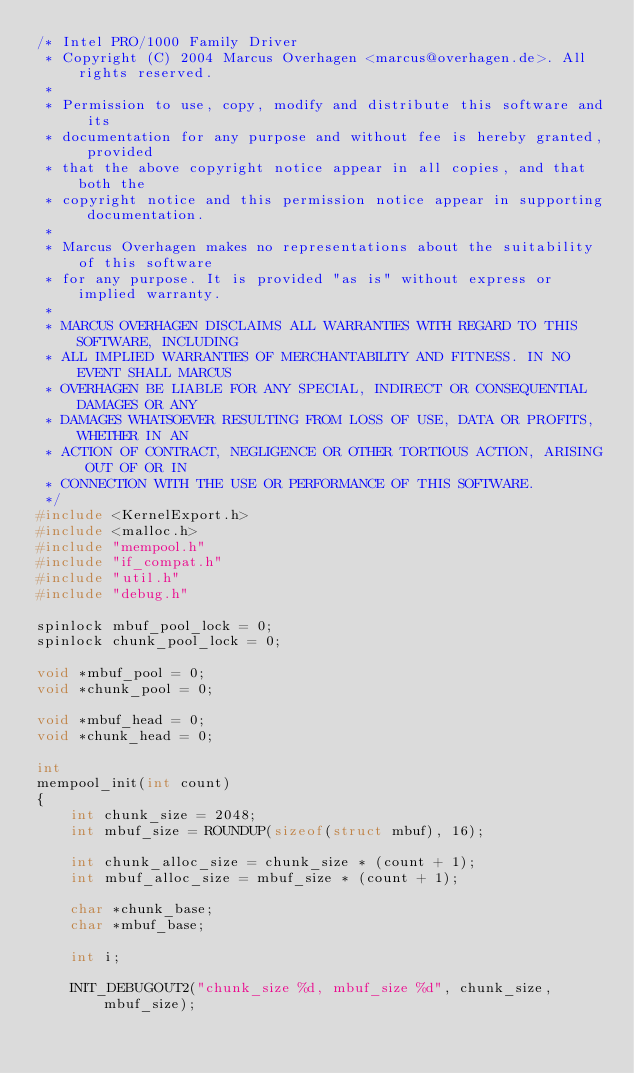<code> <loc_0><loc_0><loc_500><loc_500><_C_>/* Intel PRO/1000 Family Driver
 * Copyright (C) 2004 Marcus Overhagen <marcus@overhagen.de>. All rights reserved.
 *
 * Permission to use, copy, modify and distribute this software and its 
 * documentation for any purpose and without fee is hereby granted, provided
 * that the above copyright notice appear in all copies, and that both the
 * copyright notice and this permission notice appear in supporting documentation.
 *
 * Marcus Overhagen makes no representations about the suitability of this software
 * for any purpose. It is provided "as is" without express or implied warranty.
 *
 * MARCUS OVERHAGEN DISCLAIMS ALL WARRANTIES WITH REGARD TO THIS SOFTWARE, INCLUDING
 * ALL IMPLIED WARRANTIES OF MERCHANTABILITY AND FITNESS. IN NO EVENT SHALL MARCUS
 * OVERHAGEN BE LIABLE FOR ANY SPECIAL, INDIRECT OR CONSEQUENTIAL DAMAGES OR ANY
 * DAMAGES WHATSOEVER RESULTING FROM LOSS OF USE, DATA OR PROFITS, WHETHER IN AN
 * ACTION OF CONTRACT, NEGLIGENCE OR OTHER TORTIOUS ACTION, ARISING OUT OF OR IN
 * CONNECTION WITH THE USE OR PERFORMANCE OF THIS SOFTWARE.
 */
#include <KernelExport.h>
#include <malloc.h>
#include "mempool.h"
#include "if_compat.h"
#include "util.h"
#include "debug.h"

spinlock mbuf_pool_lock = 0;
spinlock chunk_pool_lock = 0;

void *mbuf_pool = 0;
void *chunk_pool = 0;

void *mbuf_head = 0;
void *chunk_head = 0;

int
mempool_init(int count)
{
	int chunk_size = 2048;
	int mbuf_size = ROUNDUP(sizeof(struct mbuf), 16);

	int chunk_alloc_size = chunk_size * (count + 1);
	int mbuf_alloc_size = mbuf_size * (count + 1);
	
	char *chunk_base;
	char *mbuf_base;
	
	int i;
	
	INIT_DEBUGOUT2("chunk_size %d, mbuf_size %d", chunk_size, mbuf_size);</code> 